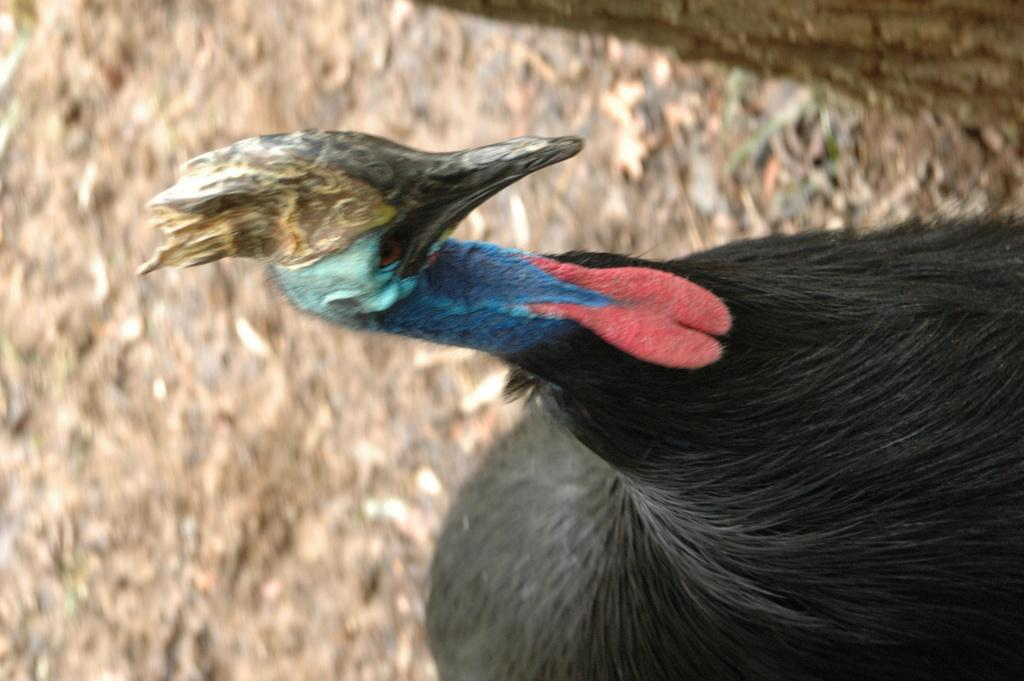What type of bird is in the image? There is a cassowary bird in the image. Can you describe the background of the image? The background of the image is blurred. What type of plane can be heard flying in the image? There is no plane present in the image, nor is there any sound mentioned. Additionally, the image is a still photograph and cannot capture sound. 